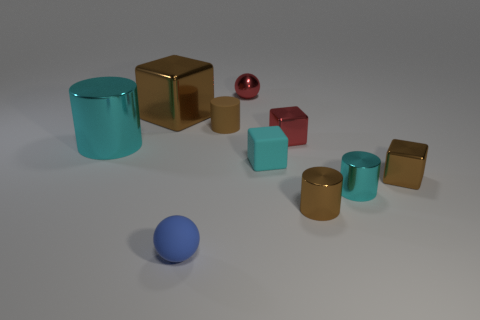How many cylinders are either small cyan objects or metal things?
Provide a short and direct response. 3. There is a ball that is behind the tiny shiny cube that is on the right side of the cyan cylinder to the right of the big brown thing; how big is it?
Your answer should be compact. Small. There is a brown rubber thing that is the same size as the shiny ball; what is its shape?
Make the answer very short. Cylinder. The tiny cyan matte thing is what shape?
Give a very brief answer. Cube. Are the tiny sphere right of the blue sphere and the cyan cube made of the same material?
Make the answer very short. No. What size is the matte object that is to the right of the sphere behind the big brown block?
Your answer should be compact. Small. There is a object that is behind the tiny brown matte object and in front of the tiny metallic ball; what color is it?
Provide a succinct answer. Brown. There is a blue object that is the same size as the red cube; what is its material?
Keep it short and to the point. Rubber. What number of other things are the same material as the cyan block?
Give a very brief answer. 2. Does the large metallic cube behind the tiny brown rubber cylinder have the same color as the small rubber object that is behind the cyan cube?
Make the answer very short. Yes. 